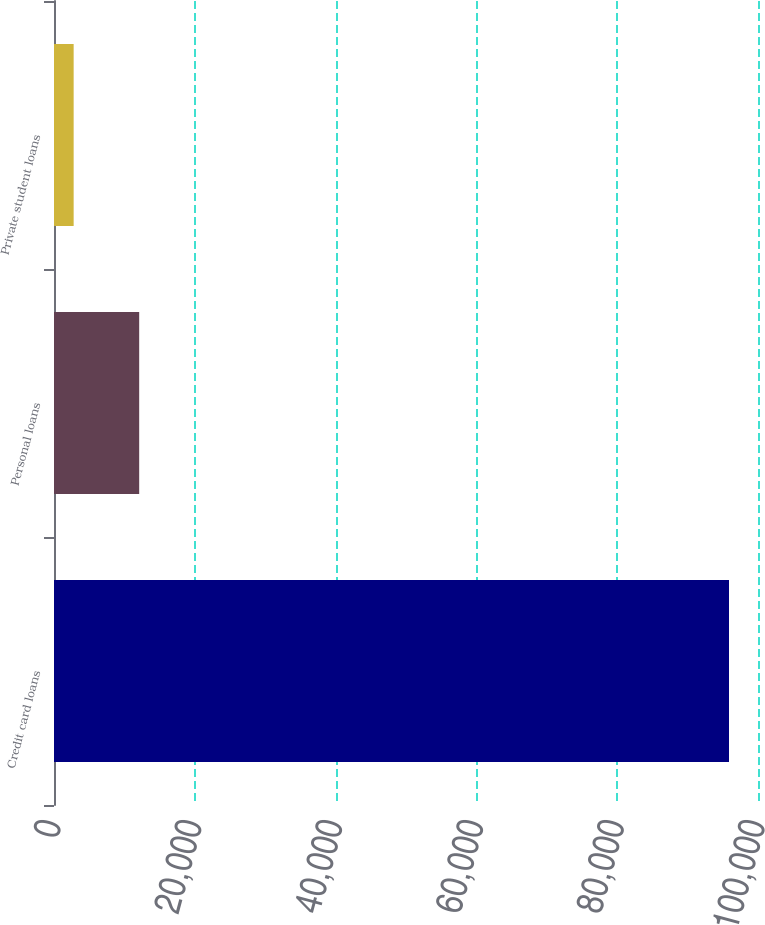Convert chart. <chart><loc_0><loc_0><loc_500><loc_500><bar_chart><fcel>Credit card loans<fcel>Personal loans<fcel>Private student loans<nl><fcel>95881<fcel>12100.9<fcel>2792<nl></chart> 